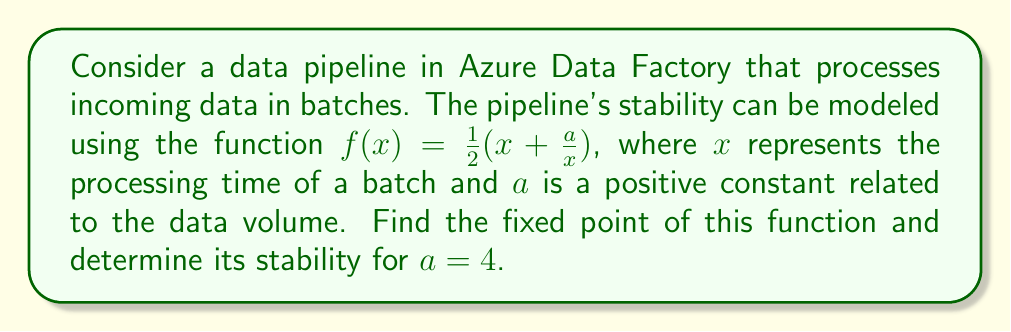Solve this math problem. 1. To find the fixed point, we set $f(x) = x$:

   $$\frac{1}{2}(x + \frac{a}{x}) = x$$

2. Multiply both sides by $2x$:

   $$x^2 + a = 2x^2$$

3. Rearrange the equation:

   $$x^2 - a = 0$$

4. Solve for x:

   $$x = \sqrt{a}$$

5. For $a = 4$, the fixed point is:

   $$x^* = \sqrt{4} = 2$$

6. To determine stability, we calculate $|f'(x^*)|$:

   $$f'(x) = \frac{1}{2}(1 - \frac{a}{x^2})$$

7. Evaluate $f'(x^*)$ at $x^* = 2$ and $a = 4$:

   $$f'(2) = \frac{1}{2}(1 - \frac{4}{2^2}) = \frac{1}{2}(1 - 1) = 0$$

8. Since $|f'(x^*)| = 0 < 1$, the fixed point is stable.

This stability indicates that the data pipeline will converge to a consistent processing time of 2 units for batches with a data volume factor of 4.
Answer: Fixed point: $x^* = 2$, Stable 